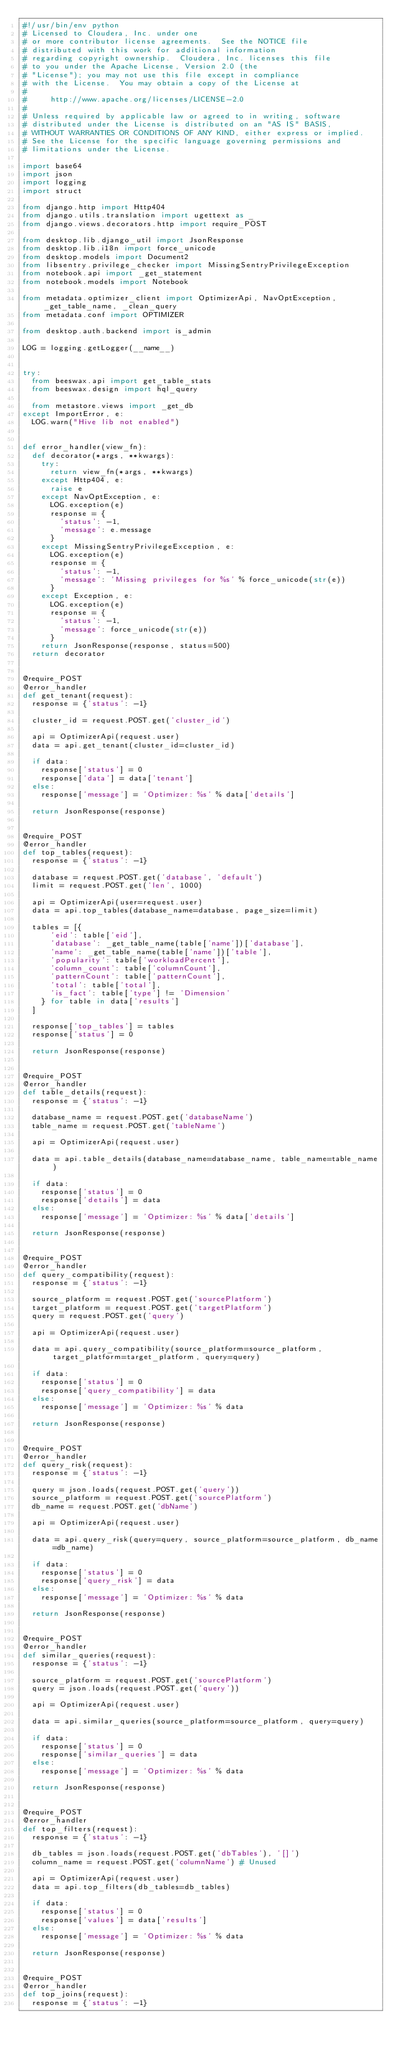Convert code to text. <code><loc_0><loc_0><loc_500><loc_500><_Python_>#!/usr/bin/env python
# Licensed to Cloudera, Inc. under one
# or more contributor license agreements.  See the NOTICE file
# distributed with this work for additional information
# regarding copyright ownership.  Cloudera, Inc. licenses this file
# to you under the Apache License, Version 2.0 (the
# "License"); you may not use this file except in compliance
# with the License.  You may obtain a copy of the License at
#
#     http://www.apache.org/licenses/LICENSE-2.0
#
# Unless required by applicable law or agreed to in writing, software
# distributed under the License is distributed on an "AS IS" BASIS,
# WITHOUT WARRANTIES OR CONDITIONS OF ANY KIND, either express or implied.
# See the License for the specific language governing permissions and
# limitations under the License.

import base64
import json
import logging
import struct

from django.http import Http404
from django.utils.translation import ugettext as _
from django.views.decorators.http import require_POST

from desktop.lib.django_util import JsonResponse
from desktop.lib.i18n import force_unicode
from desktop.models import Document2
from libsentry.privilege_checker import MissingSentryPrivilegeException
from notebook.api import _get_statement
from notebook.models import Notebook

from metadata.optimizer_client import OptimizerApi, NavOptException, _get_table_name, _clean_query
from metadata.conf import OPTIMIZER

from desktop.auth.backend import is_admin

LOG = logging.getLogger(__name__)


try:
  from beeswax.api import get_table_stats
  from beeswax.design import hql_query

  from metastore.views import _get_db
except ImportError, e:
  LOG.warn("Hive lib not enabled")


def error_handler(view_fn):
  def decorator(*args, **kwargs):
    try:
      return view_fn(*args, **kwargs)
    except Http404, e:
      raise e
    except NavOptException, e:
      LOG.exception(e)
      response = {
        'status': -1,
        'message': e.message
      }
    except MissingSentryPrivilegeException, e:
      LOG.exception(e)
      response = {
        'status': -1,
        'message': 'Missing privileges for %s' % force_unicode(str(e))
      }
    except Exception, e:
      LOG.exception(e)
      response = {
        'status': -1,
        'message': force_unicode(str(e))
      }
    return JsonResponse(response, status=500)
  return decorator


@require_POST
@error_handler
def get_tenant(request):
  response = {'status': -1}

  cluster_id = request.POST.get('cluster_id')

  api = OptimizerApi(request.user)
  data = api.get_tenant(cluster_id=cluster_id)

  if data:
    response['status'] = 0
    response['data'] = data['tenant']
  else:
    response['message'] = 'Optimizer: %s' % data['details']

  return JsonResponse(response)


@require_POST
@error_handler
def top_tables(request):
  response = {'status': -1}

  database = request.POST.get('database', 'default')
  limit = request.POST.get('len', 1000)

  api = OptimizerApi(user=request.user)
  data = api.top_tables(database_name=database, page_size=limit)

  tables = [{
      'eid': table['eid'],
      'database': _get_table_name(table['name'])['database'],
      'name': _get_table_name(table['name'])['table'],
      'popularity': table['workloadPercent'],
      'column_count': table['columnCount'],
      'patternCount': table['patternCount'],
      'total': table['total'],
      'is_fact': table['type'] != 'Dimension'
    } for table in data['results']
  ]

  response['top_tables'] = tables
  response['status'] = 0

  return JsonResponse(response)


@require_POST
@error_handler
def table_details(request):
  response = {'status': -1}

  database_name = request.POST.get('databaseName')
  table_name = request.POST.get('tableName')

  api = OptimizerApi(request.user)

  data = api.table_details(database_name=database_name, table_name=table_name)

  if data:
    response['status'] = 0
    response['details'] = data
  else:
    response['message'] = 'Optimizer: %s' % data['details']

  return JsonResponse(response)


@require_POST
@error_handler
def query_compatibility(request):
  response = {'status': -1}

  source_platform = request.POST.get('sourcePlatform')
  target_platform = request.POST.get('targetPlatform')
  query = request.POST.get('query')

  api = OptimizerApi(request.user)

  data = api.query_compatibility(source_platform=source_platform, target_platform=target_platform, query=query)

  if data:
    response['status'] = 0
    response['query_compatibility'] = data
  else:
    response['message'] = 'Optimizer: %s' % data

  return JsonResponse(response)


@require_POST
@error_handler
def query_risk(request):
  response = {'status': -1}

  query = json.loads(request.POST.get('query'))
  source_platform = request.POST.get('sourcePlatform')
  db_name = request.POST.get('dbName')

  api = OptimizerApi(request.user)

  data = api.query_risk(query=query, source_platform=source_platform, db_name=db_name)

  if data:
    response['status'] = 0
    response['query_risk'] = data
  else:
    response['message'] = 'Optimizer: %s' % data

  return JsonResponse(response)


@require_POST
@error_handler
def similar_queries(request):
  response = {'status': -1}

  source_platform = request.POST.get('sourcePlatform')
  query = json.loads(request.POST.get('query'))

  api = OptimizerApi(request.user)

  data = api.similar_queries(source_platform=source_platform, query=query)

  if data:
    response['status'] = 0
    response['similar_queries'] = data
  else:
    response['message'] = 'Optimizer: %s' % data

  return JsonResponse(response)


@require_POST
@error_handler
def top_filters(request):
  response = {'status': -1}

  db_tables = json.loads(request.POST.get('dbTables'), '[]')
  column_name = request.POST.get('columnName') # Unused

  api = OptimizerApi(request.user)
  data = api.top_filters(db_tables=db_tables)

  if data:
    response['status'] = 0
    response['values'] = data['results']
  else:
    response['message'] = 'Optimizer: %s' % data

  return JsonResponse(response)


@require_POST
@error_handler
def top_joins(request):
  response = {'status': -1}
</code> 